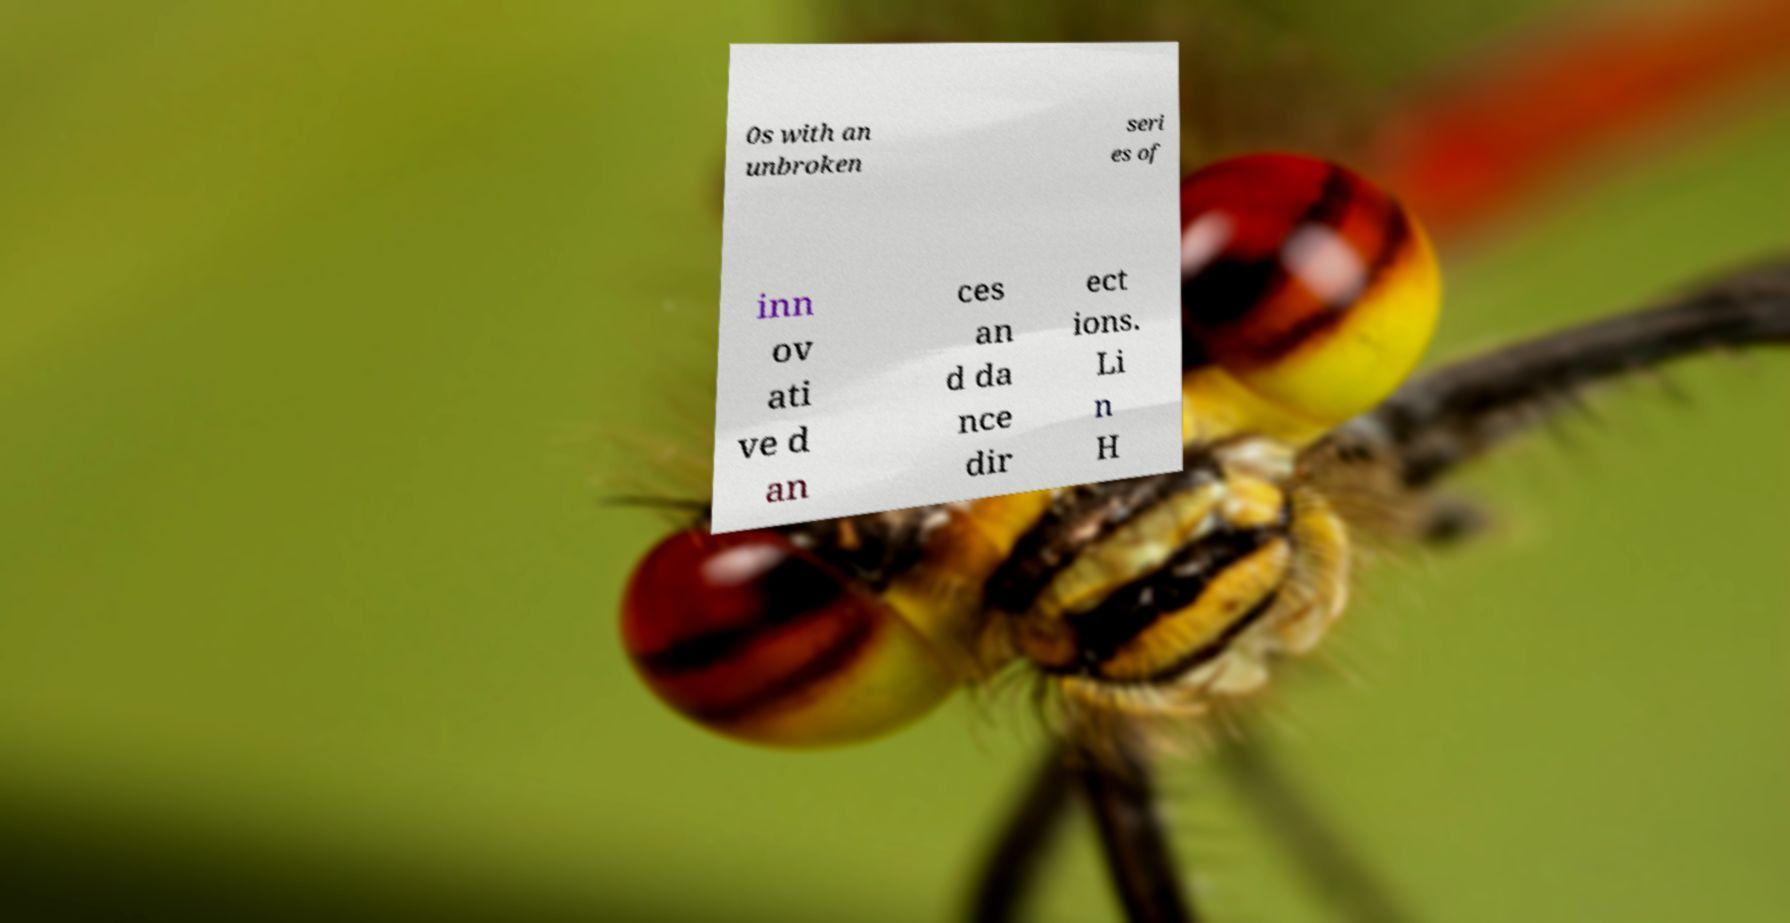Please read and relay the text visible in this image. What does it say? 0s with an unbroken seri es of inn ov ati ve d an ces an d da nce dir ect ions. Li n H 